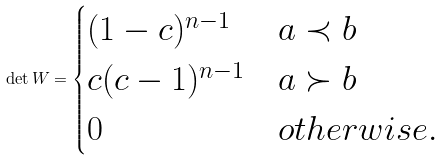Convert formula to latex. <formula><loc_0><loc_0><loc_500><loc_500>\det W = \begin{cases} ( 1 - c ) ^ { n - 1 } & a \prec b \\ c ( c - 1 ) ^ { n - 1 } & a \succ b \\ 0 & o t h e r w i s e . \end{cases}</formula> 